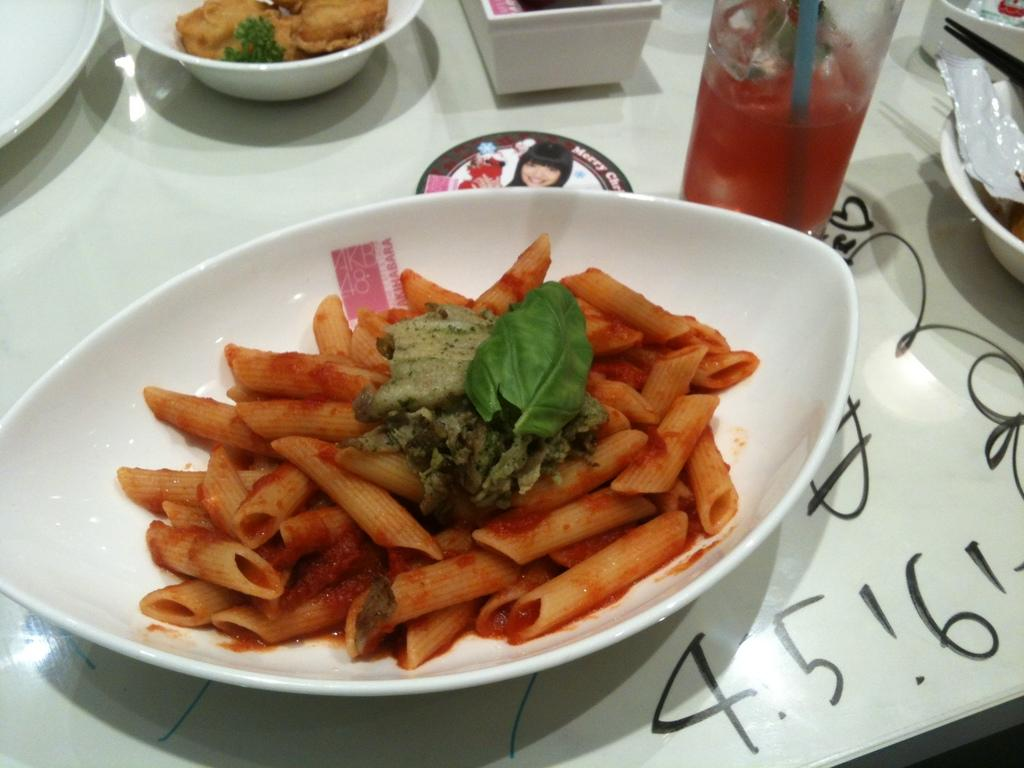What is located on the left side of the image? There are food items arranged in a bowl on the left side of the image. Where is the bowl placed? The bowl is placed on a table. What other items can be seen on the table? There are cups, a plate, and a glass on the table. What is the color of the background in the image? The background of the image is white in color. Can you hear the bell ringing in the image? There is no bell present in the image, so it cannot be heard ringing. 